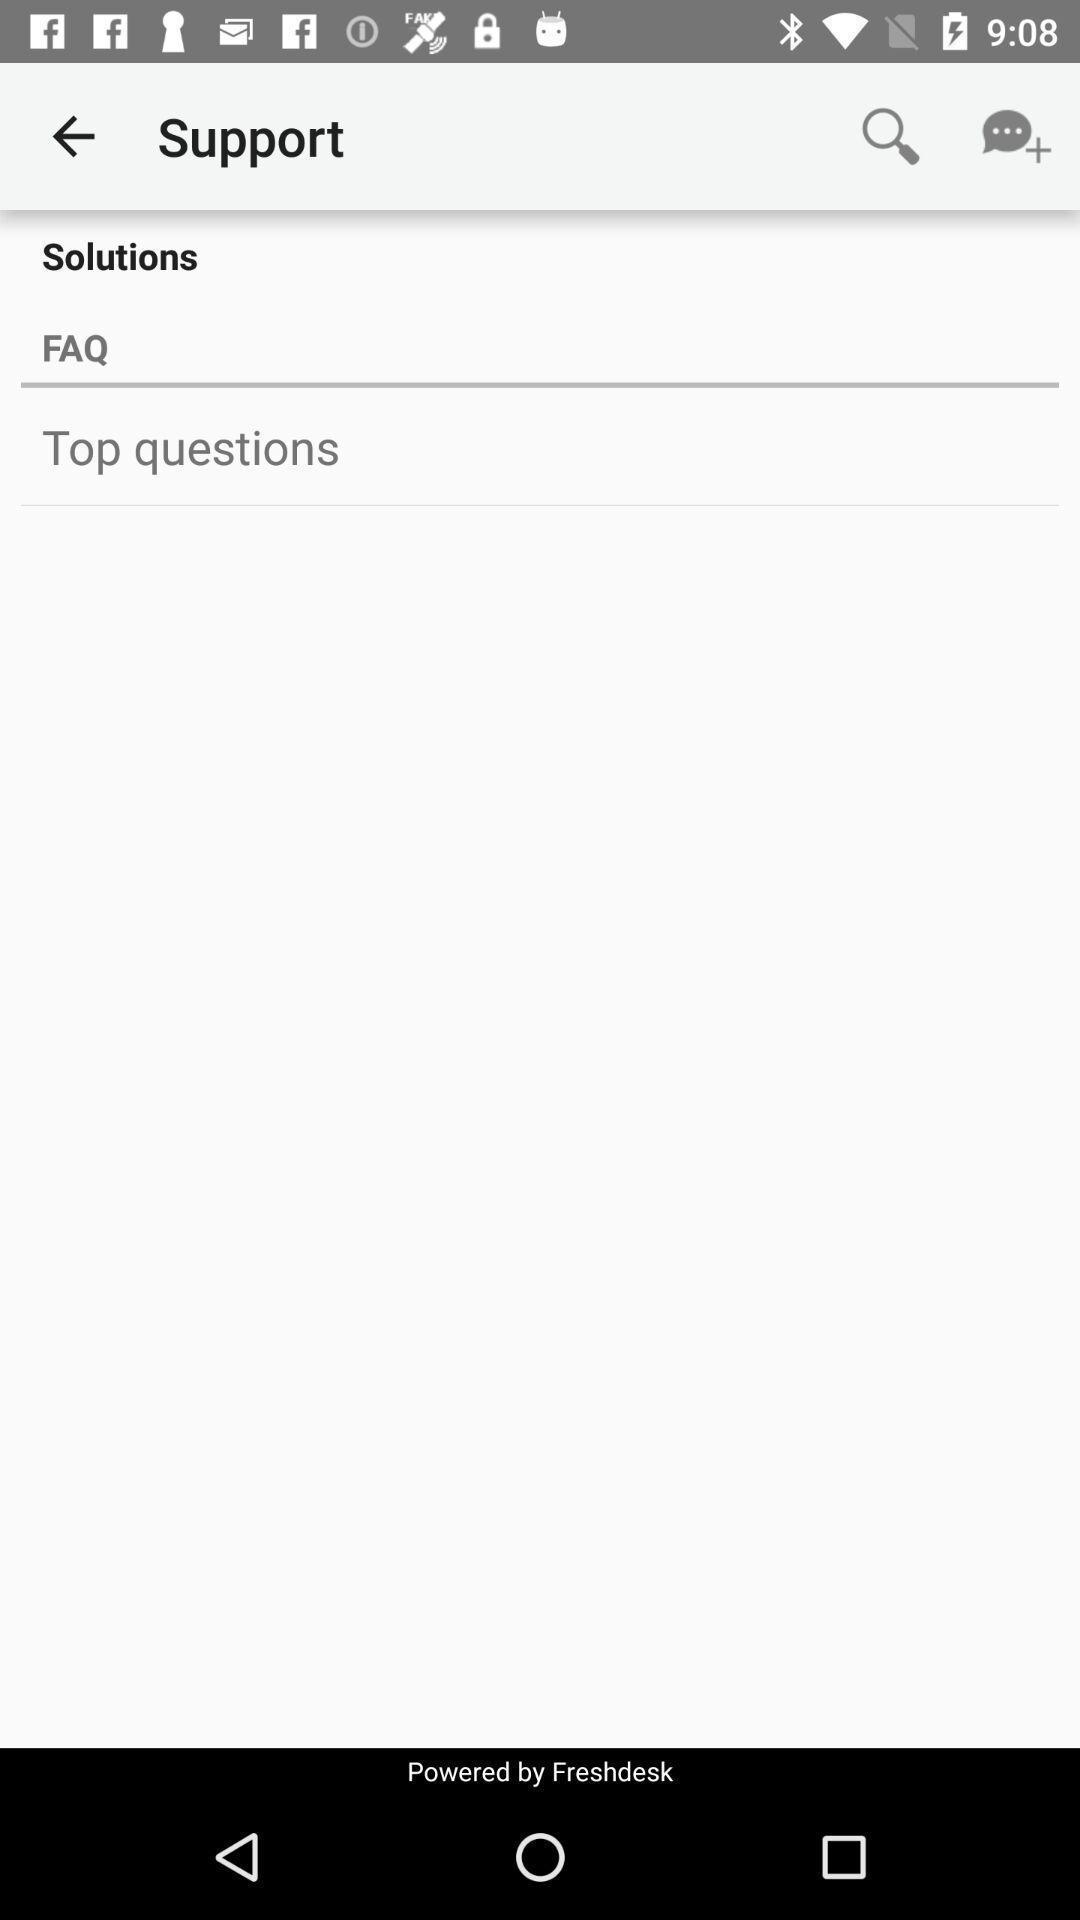Describe the key features of this screenshot. Top questions in solutions in support. 